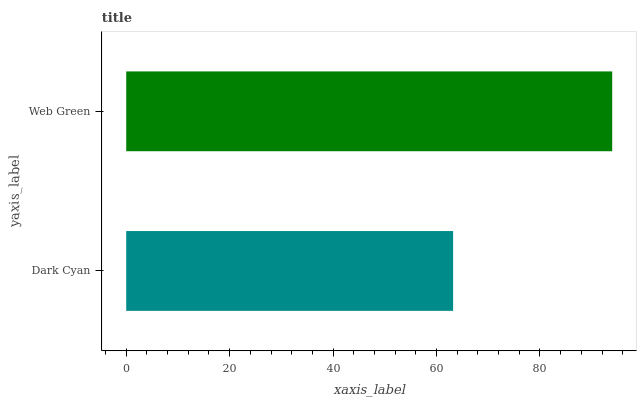Is Dark Cyan the minimum?
Answer yes or no. Yes. Is Web Green the maximum?
Answer yes or no. Yes. Is Web Green the minimum?
Answer yes or no. No. Is Web Green greater than Dark Cyan?
Answer yes or no. Yes. Is Dark Cyan less than Web Green?
Answer yes or no. Yes. Is Dark Cyan greater than Web Green?
Answer yes or no. No. Is Web Green less than Dark Cyan?
Answer yes or no. No. Is Web Green the high median?
Answer yes or no. Yes. Is Dark Cyan the low median?
Answer yes or no. Yes. Is Dark Cyan the high median?
Answer yes or no. No. Is Web Green the low median?
Answer yes or no. No. 